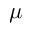<formula> <loc_0><loc_0><loc_500><loc_500>\mu</formula> 